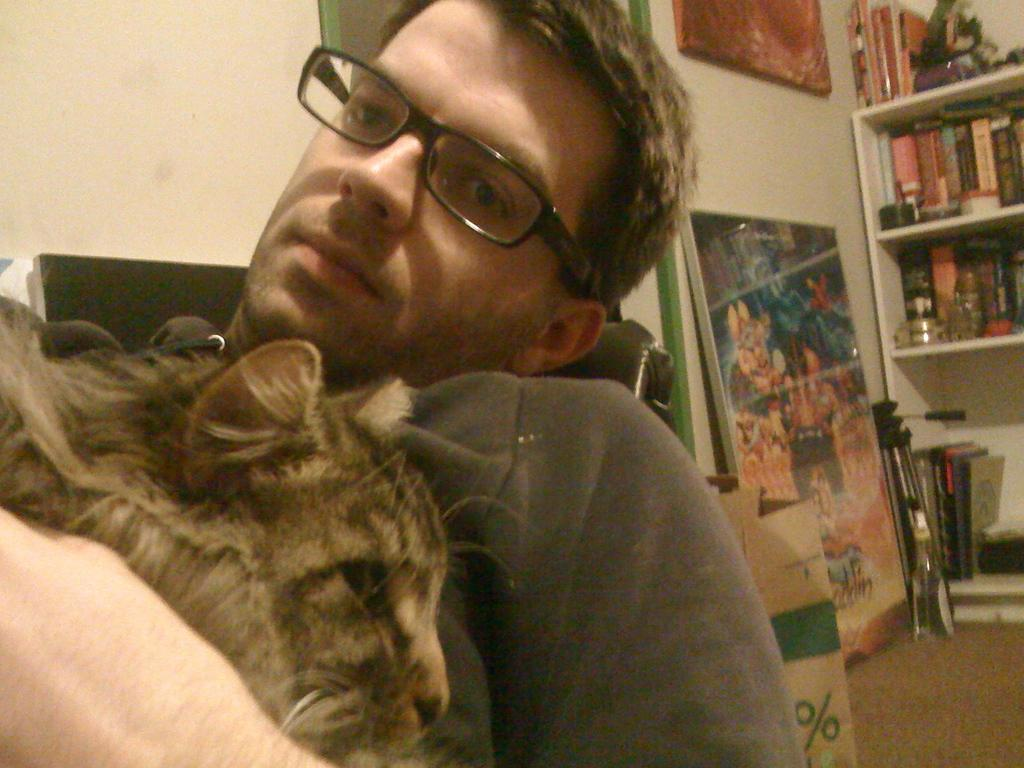What is the main subject of the image? There is a person in the image. What can be seen on the person's face? The person is wearing spectacles. What is the person holding in the image? The person is holding a cat. What is on the wall in the image? There is a painting on the wall in the image. What is located on the right side of the image? There is a cupboard on the right side of the image. What is inside the cupboard? The cupboard contains some books. What historical event is depicted in the painting on the wall? There is no information about the content of the painting in the image, so it cannot be determined if it depicts a historical event. What does the person desire in the image? There is no information about the person's desires in the image, so it cannot be determined what they desire. 